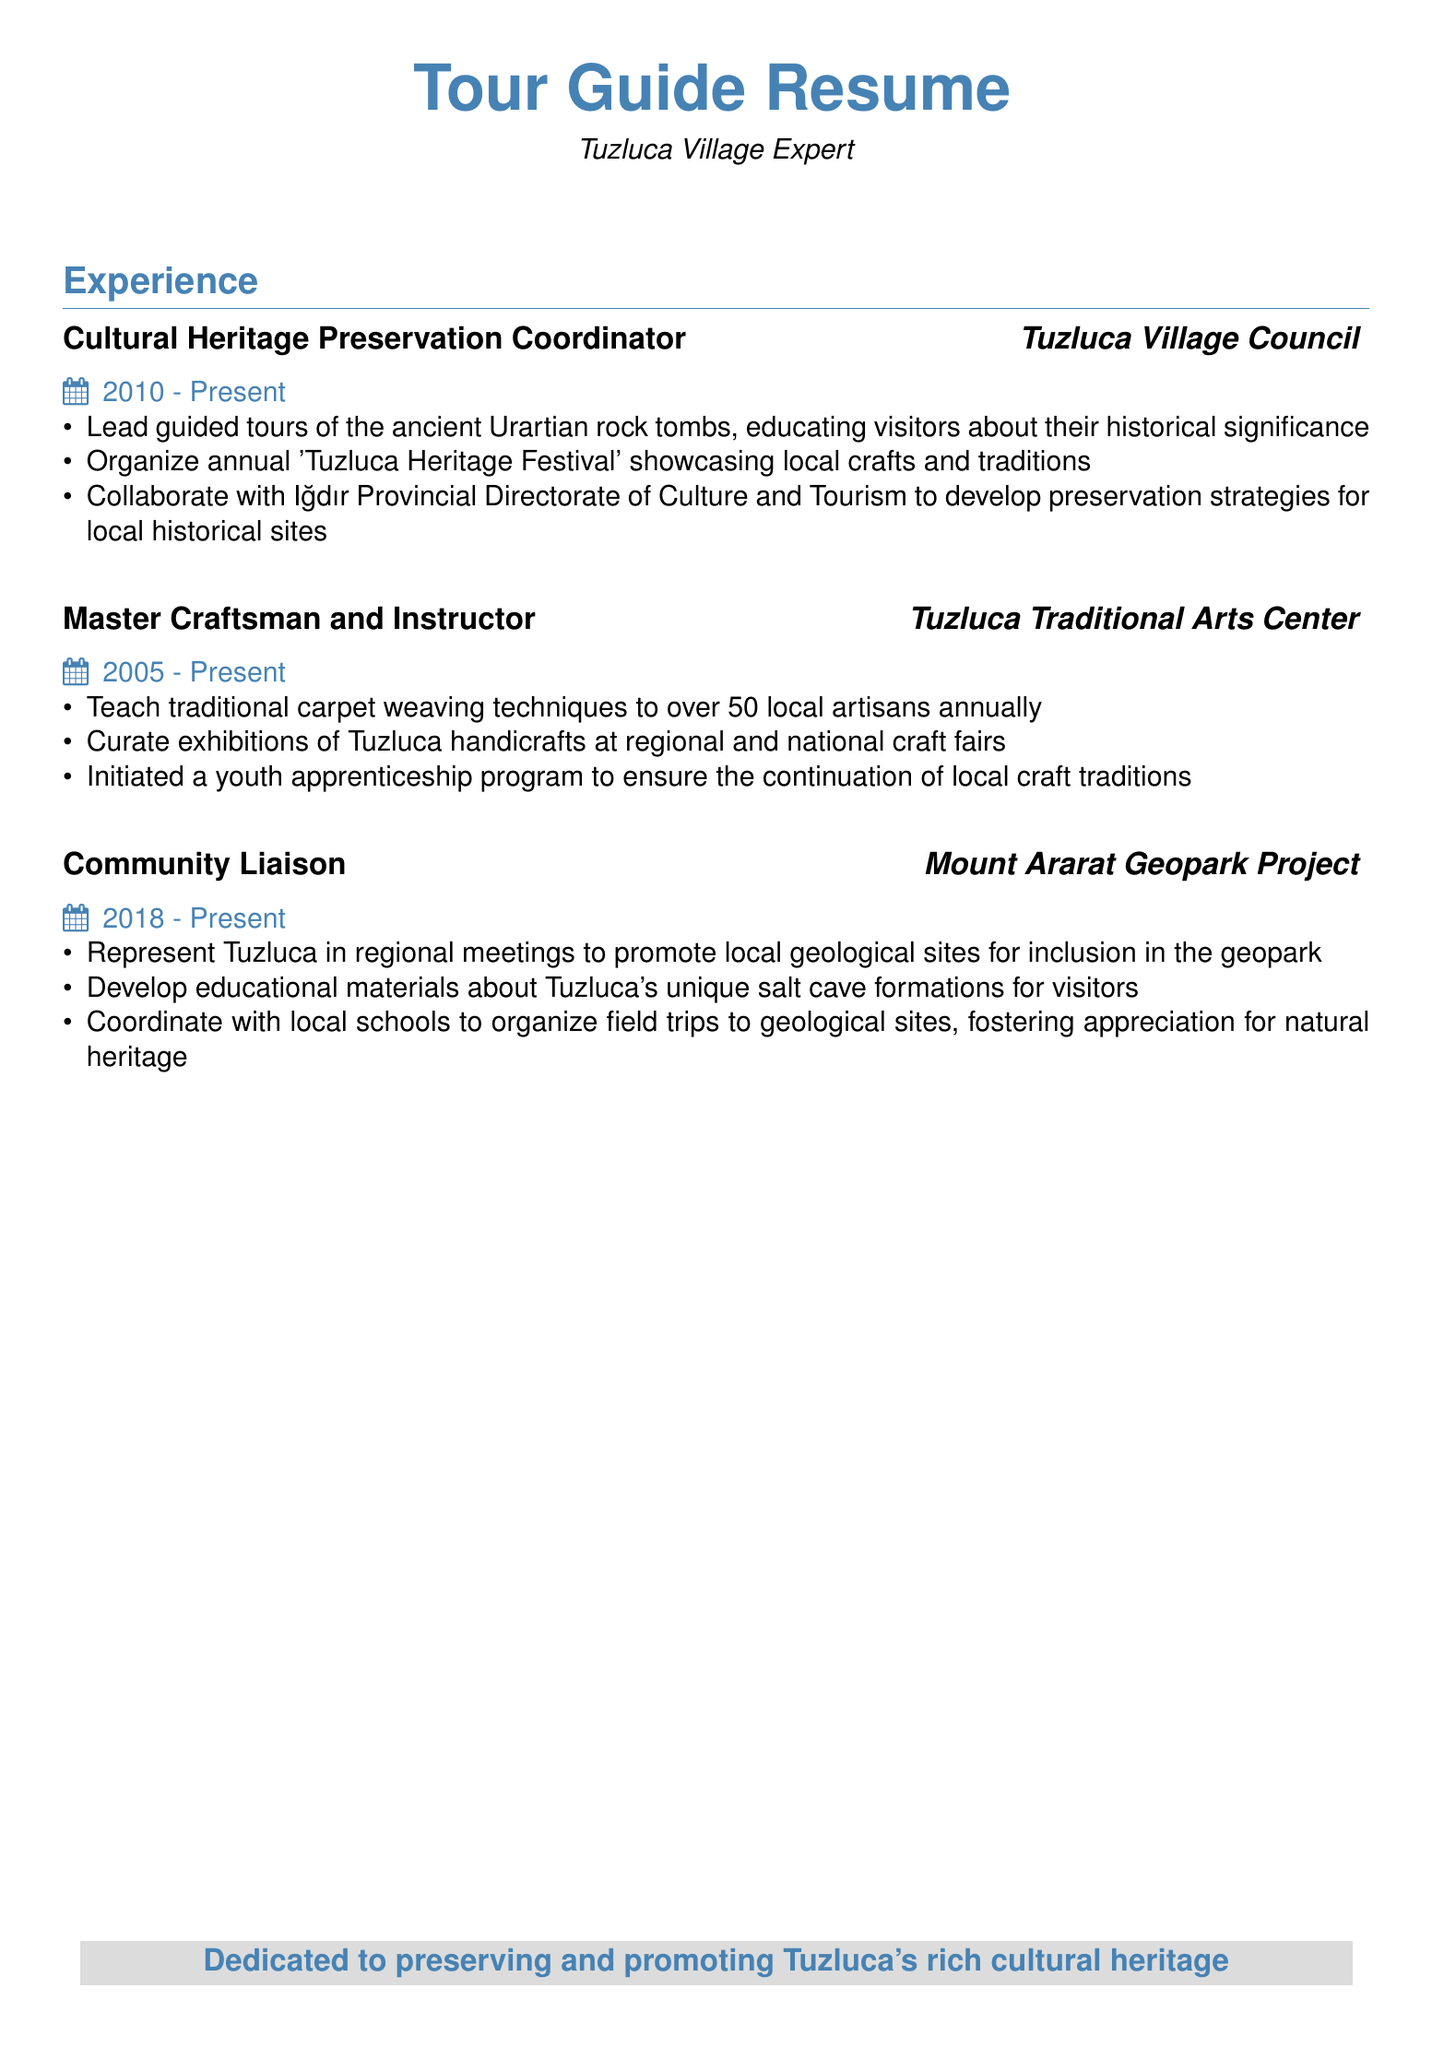What is the title of the first position listed? The first position in the experience section is stated as "Cultural Heritage Preservation Coordinator" under Tuzluca Village Council.
Answer: Cultural Heritage Preservation Coordinator How long has the Master Craftsman and Instructor been in the role? The document indicates that the duration for this position is from 2005 to present, which implies a span of 18 years as of now.
Answer: 18 years Which festival does the Cultural Heritage Preservation Coordinator organize? The coordinator is responsible for organizing the annual 'Tuzluca Heritage Festival', which is mentioned in the responsibilities.
Answer: Tuzluca Heritage Festival What is one of the contributions of the Community Liaison role? One of the contributions mentioned is developing educational materials about Tuzluca's unique salt cave formations for visitors.
Answer: Develop educational materials How many local artisans does the Master Craftsman teach annually? It is stated that the Master Craftsman teaches traditional carpet weaving techniques to over 50 local artisans each year.
Answer: Over 50 local artisans What organization collaborates with the Cultural Heritage Preservation Coordinator? The Coordinator collaborates with the Iğdır Provincial Directorate of Culture and Tourism for developing preservation strategies.
Answer: Iğdır Provincial Directorate of Culture and Tourism What is the main goal of the youth apprenticeship program initiated? The youth apprenticeship program aims to ensure the continuation of local craft traditions, as stated in the achievements of the Master Craftsman.
Answer: Local craft traditions In which project is the Community Liaison involved? The Community Liaison position is part of the Mount Ararat Geopark Project, as indicated in the experience section.
Answer: Mount Ararat Geopark Project 